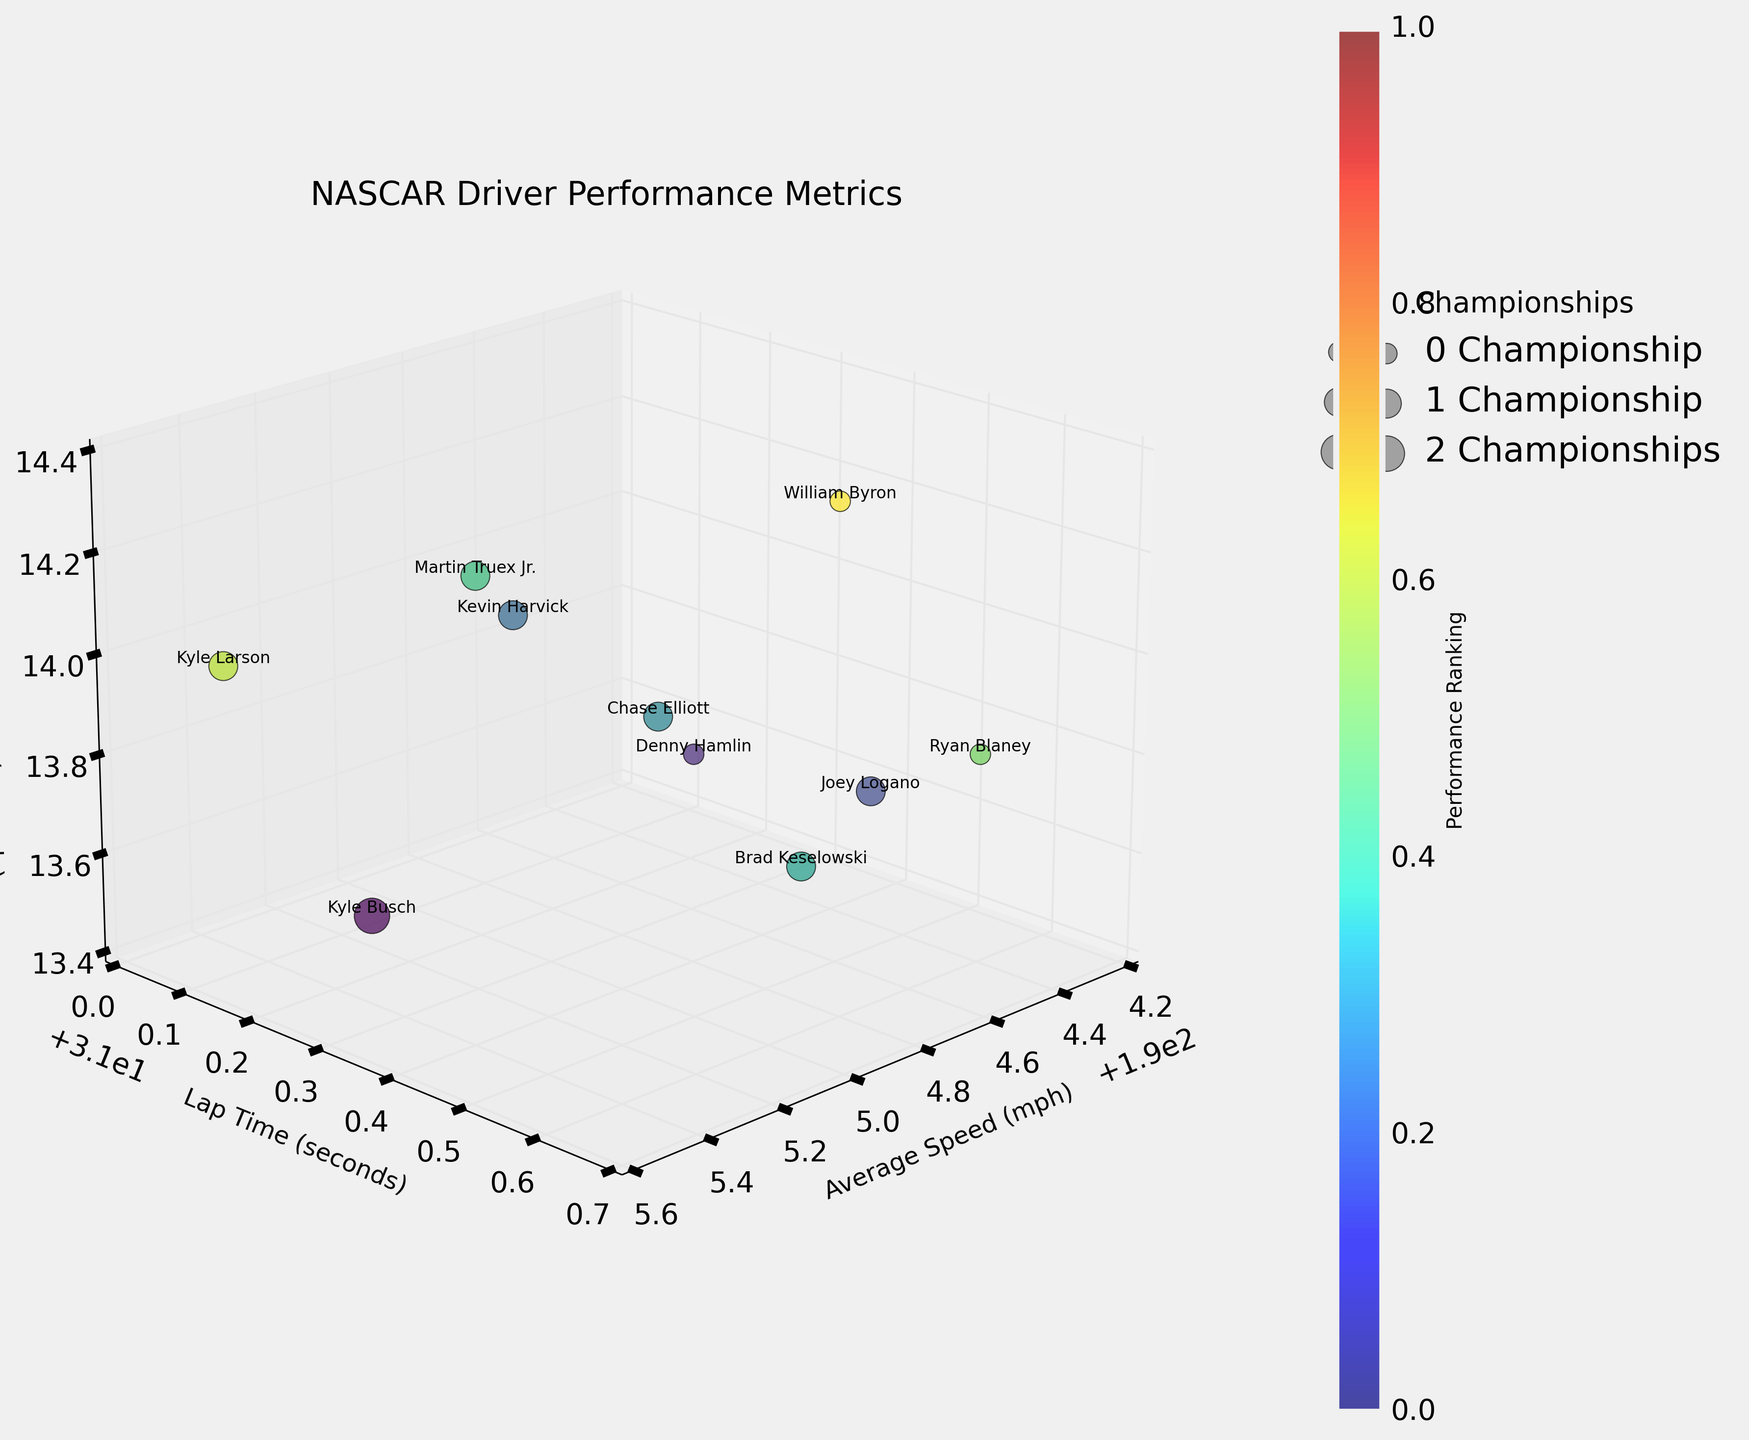How many drivers have achieved more than one championship? We need to check the legend indicating the number of championships. The legend shows the bubble size for each championship value. The largest bubbles correspond to drivers with 2 championships. Only Kyle Busch has a bubble that large.
Answer: 1 Which driver has the fastest average speed? Look for the highest point on the 'Average Speed (mph)' axis. Kyle Larson has the highest value.
Answer: Kyle Larson What's the range of lap times among the drivers? Identify the lowest and highest points on the 'Lap Time (seconds)' axis. The lowest lap time is 31.1 (Kyle Larson) and the highest is 31.6 (Ryan Blaney), so the range is 31.6 - 31.1.
Answer: 0.5 seconds What's the average pit stop efficiency for drivers who have won a championship? Identify the bubbles for drivers with championships by their size, then locate their 'Pit Stop Efficiency (seconds)' values: Joey Logano (13.7), Kevin Harvick (14.1), Chase Elliott (13.9), Brad Keselowski (13.6), Martin Truex Jr. (14.2), Kyle Larson (14.0). Sum these values and divide by the number of championship-winning drivers. Sum = 83.5, number of drivers = 6, average = 83.5 / 6.
Answer: 13.92 seconds Which driver has the highest pit stop efficiency and more than zero championships? Identify the largest bubbles and then the highest 'Pit Stop Efficiency (seconds)' value among them. Martin Truex Jr. has the highest value.
Answer: Martin Truex Jr Which driver has the best combination of speed and pit stop efficiency? Look for the driver who is farthest front and lowest in the 3D space combination of speed and pit stop. The best combination would be a high speed and a low pit stop efficiency. Kyle Larson appears to be both fastest and relatively efficient.
Answer: Kyle Larson What is the total number of championships across all drivers? Sum the 'Championships' values for all drivers. Total = 2 + 0 + 1 + 1 + 1 + 1 + 1 + 0 + 1 + 0.
Answer: 8 